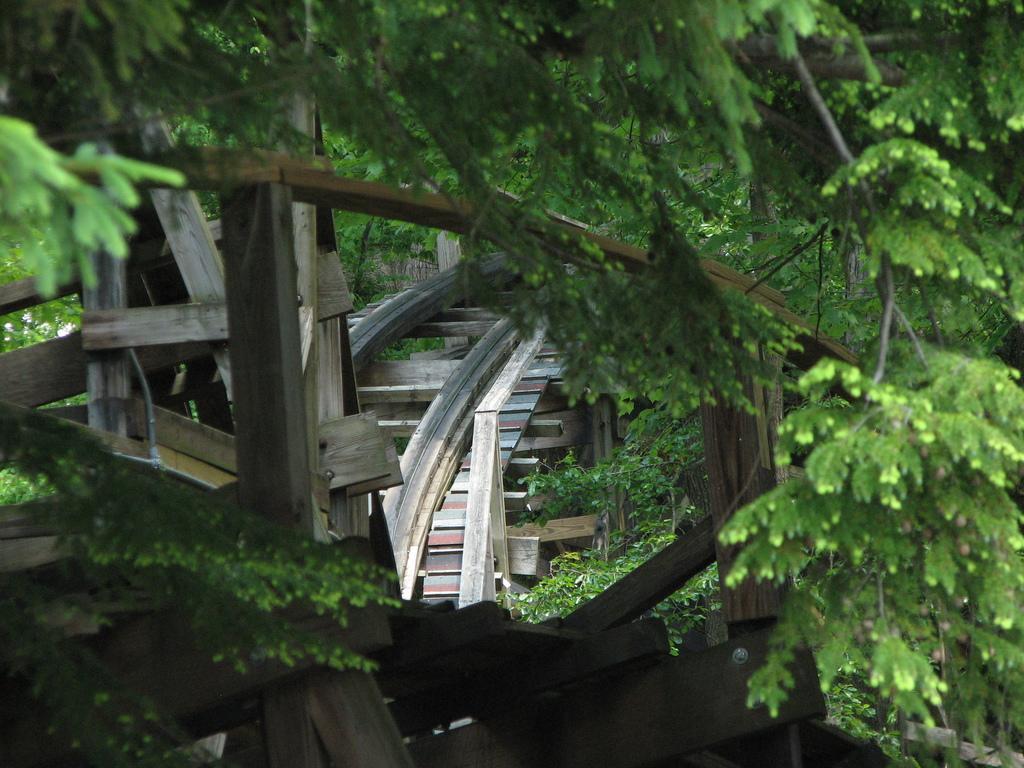Describe this image in one or two sentences. In this picture we can see trees. 